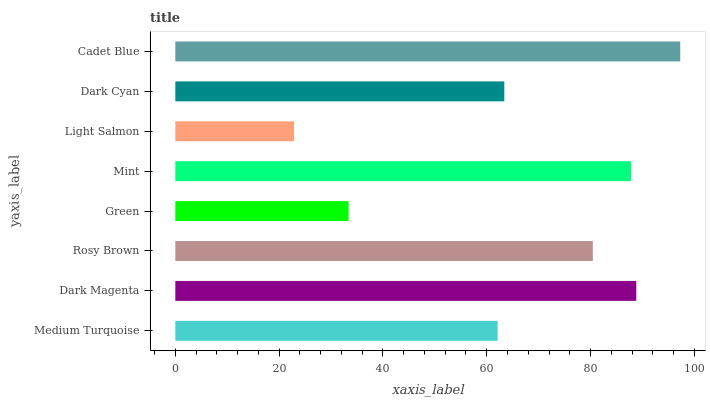Is Light Salmon the minimum?
Answer yes or no. Yes. Is Cadet Blue the maximum?
Answer yes or no. Yes. Is Dark Magenta the minimum?
Answer yes or no. No. Is Dark Magenta the maximum?
Answer yes or no. No. Is Dark Magenta greater than Medium Turquoise?
Answer yes or no. Yes. Is Medium Turquoise less than Dark Magenta?
Answer yes or no. Yes. Is Medium Turquoise greater than Dark Magenta?
Answer yes or no. No. Is Dark Magenta less than Medium Turquoise?
Answer yes or no. No. Is Rosy Brown the high median?
Answer yes or no. Yes. Is Dark Cyan the low median?
Answer yes or no. Yes. Is Mint the high median?
Answer yes or no. No. Is Mint the low median?
Answer yes or no. No. 